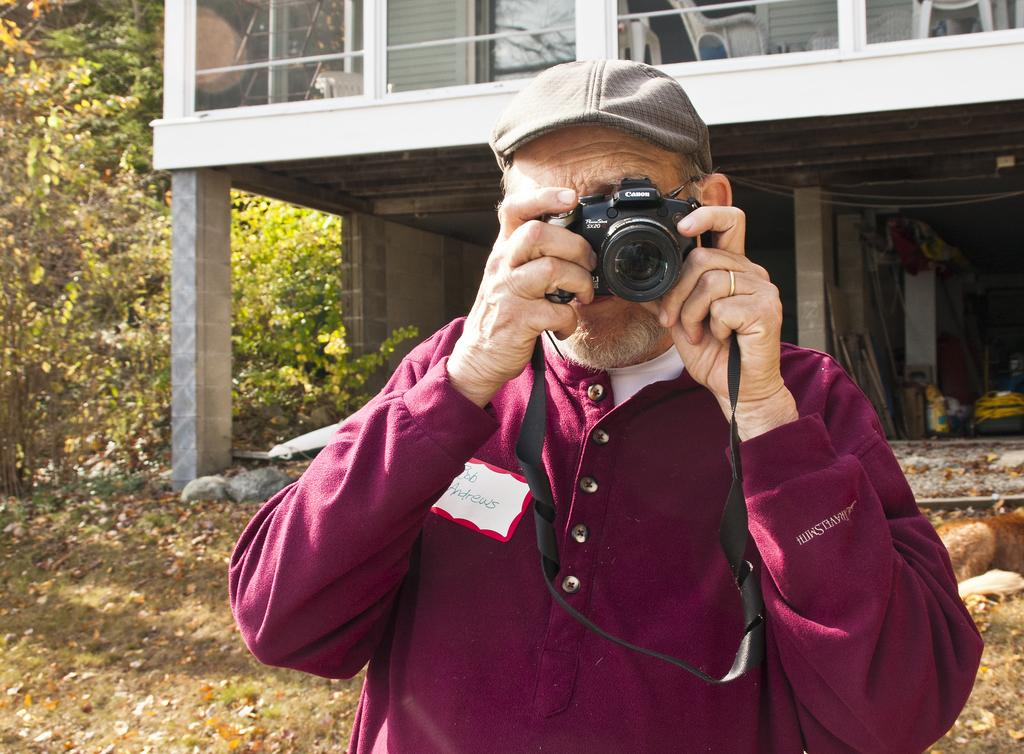What is the person holding in the image? The person is holding a camera and a wire cap. Can you describe the house in the image? The house in the image has windows. What type of vegetation can be seen in the image? There are plants and trees in the image. What type of sound can be heard coming from the house in the image? There is no information about any sounds in the image, so it cannot be determined what type of sound might be heard. 